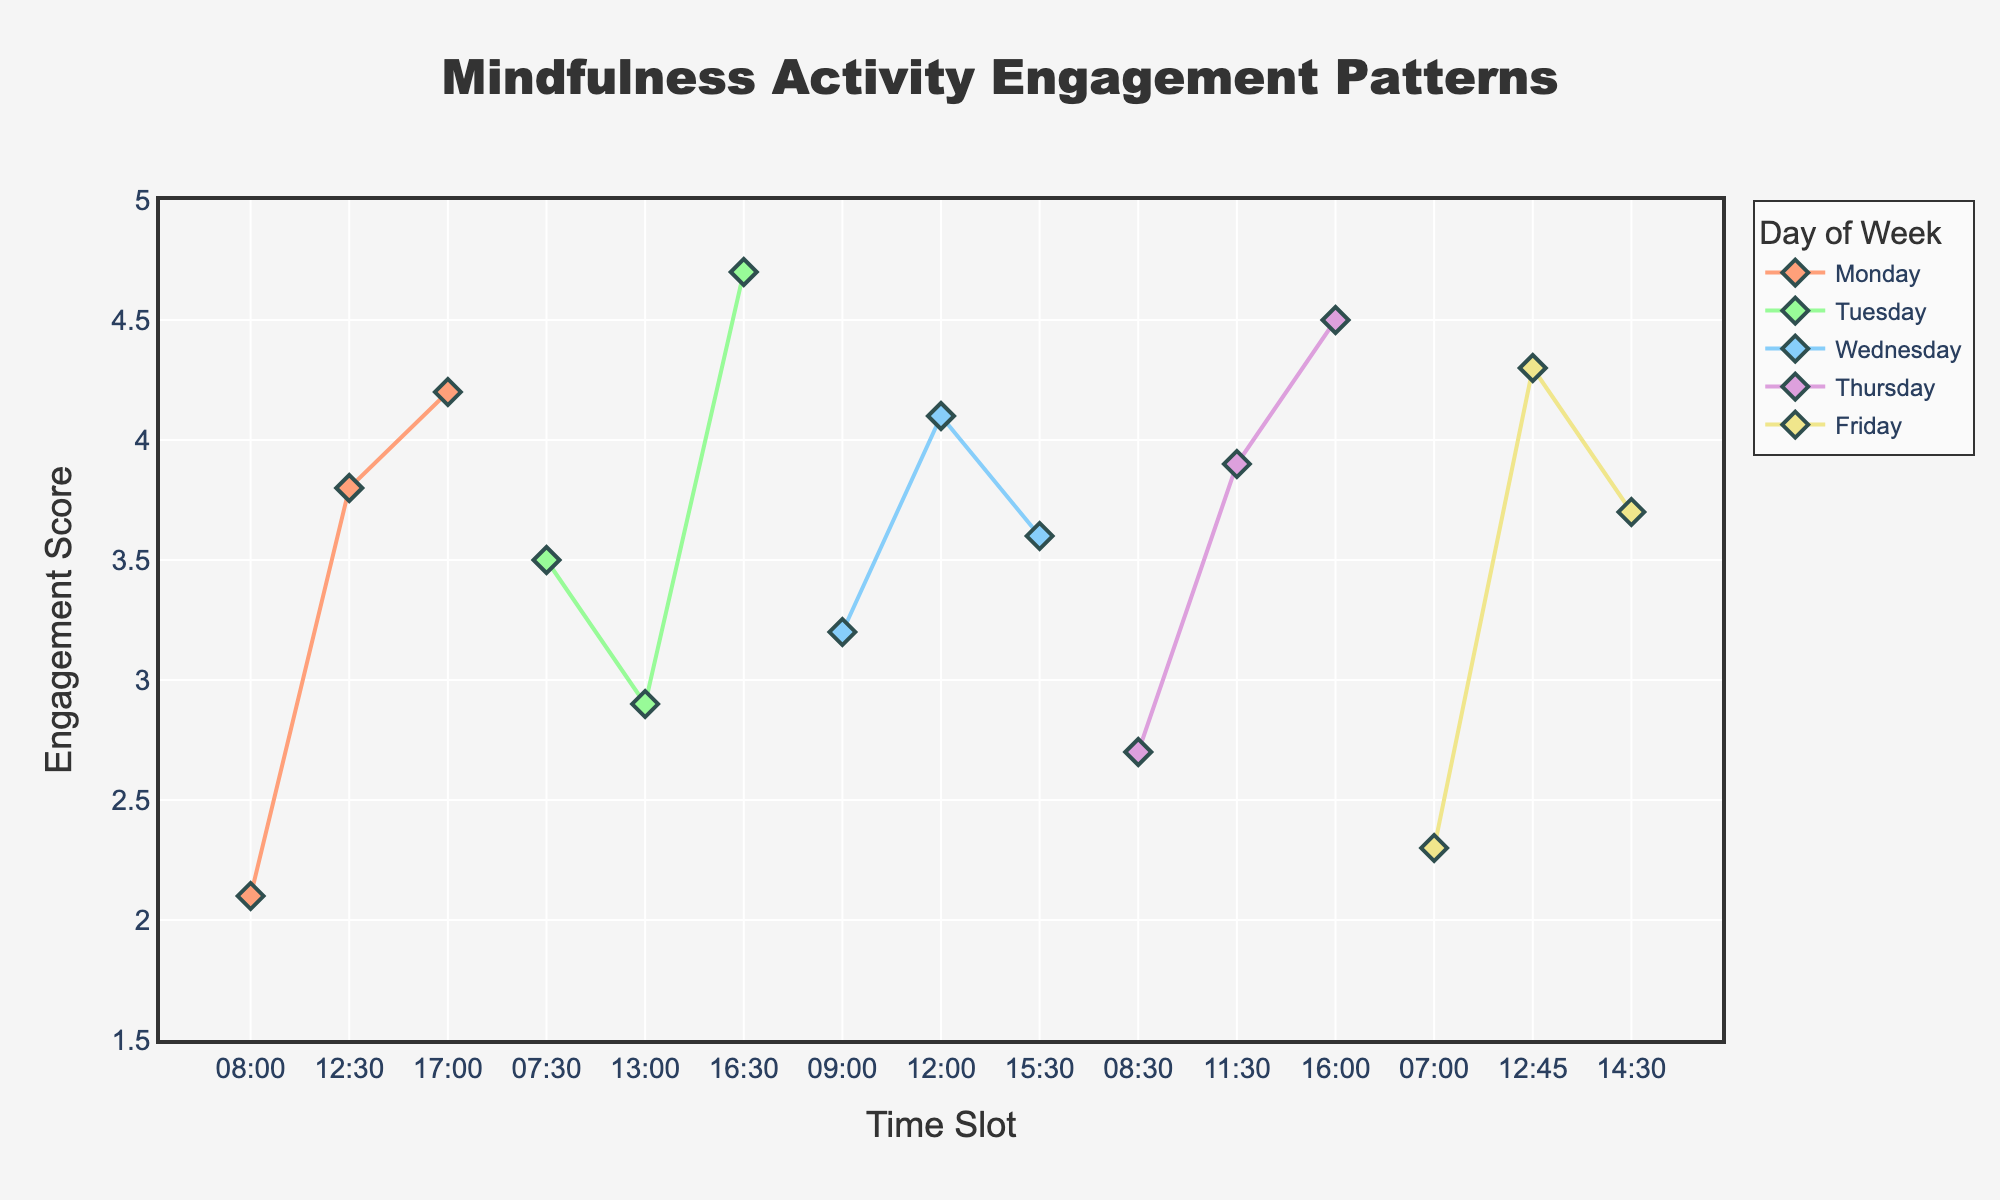How many days of the week are represented in the plot? The plot uses different color lines to represent each day. Counting the number of unique lines gives the total number of days.
Answer: 5 What is the engagement score for the time slot 13:00 on Tuesday? Locate Tuesday’s line in the plot, then find the marker position at 13:00 on the x-axis. The corresponding y-value is the engagement score.
Answer: 2.9 Which day has the highest peak engagement score and what is that score? By observing the y-values at the peak for each line, identify the highest value and its corresponding day.
Answer: Tuesday, 4.7 Is the engagement score at 07:00 on Friday above or below the average engagement score shown in the plot? First, find the average engagement score across all data points, then compare the score at 07:00 on Friday with this average.
Answer: Below What is the average engagement score for all time slots on Monday? Add up the engagement scores for Monday and divide by the number of time slots on Monday.
Answer: 3.37 Which time slot on Thursday has the highest engagement score? Examine Thursday's line and find the time slot corresponding to its highest y-value.
Answer: 16:00 Between 08:00 and 17:00 on Monday, at which time slot is the engagement the lowest, and what is that score? Compare all the engagement scores for Monday between 08:00 and 17:00 to find the minimum value and its corresponding time slot.
Answer: 08:00, 2.1 On which day is the engagement score trend generally increasing as the day progresses, and what is the overall trend for that day? Examine the slope of the line throughout the day for each day to identify an overall increasing pattern.
Answer: Thursday, increasing How does the engagement pattern on Wednesday compare to Friday? Compare the shape and position of the lines for Wednesday and Friday to determine similarities or differences in engagement score trends.
Answer: Both have mid-day peaks, but Friday has a generally higher trend Calculate the difference in engagement score between 15:30 and 17:00 on Monday. What does this imply about engagement in late afternoons? Subtract the engagement score at 15:30 from that at 17:00 for Monday to find the difference. This helps understand engagement changes through the late afternoon.
Answer: 0.6 